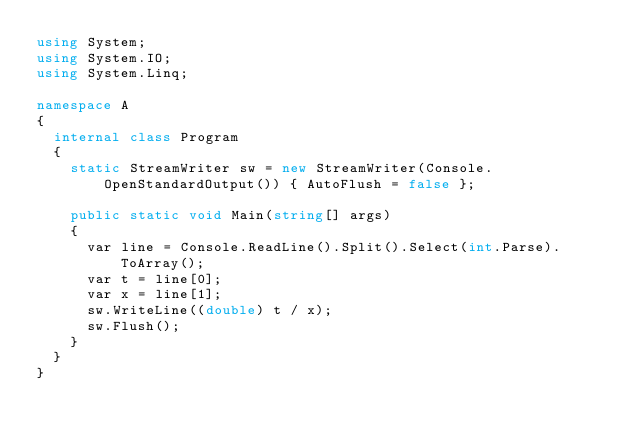<code> <loc_0><loc_0><loc_500><loc_500><_C#_>using System;
using System.IO;
using System.Linq;

namespace A
{
	internal class Program
	{
		static StreamWriter sw = new StreamWriter(Console.OpenStandardOutput()) { AutoFlush = false };

		public static void Main(string[] args)
		{
			var line = Console.ReadLine().Split().Select(int.Parse).ToArray();
			var t = line[0];
			var x = line[1];
			sw.WriteLine((double) t / x);
			sw.Flush();
		}
	}
}</code> 